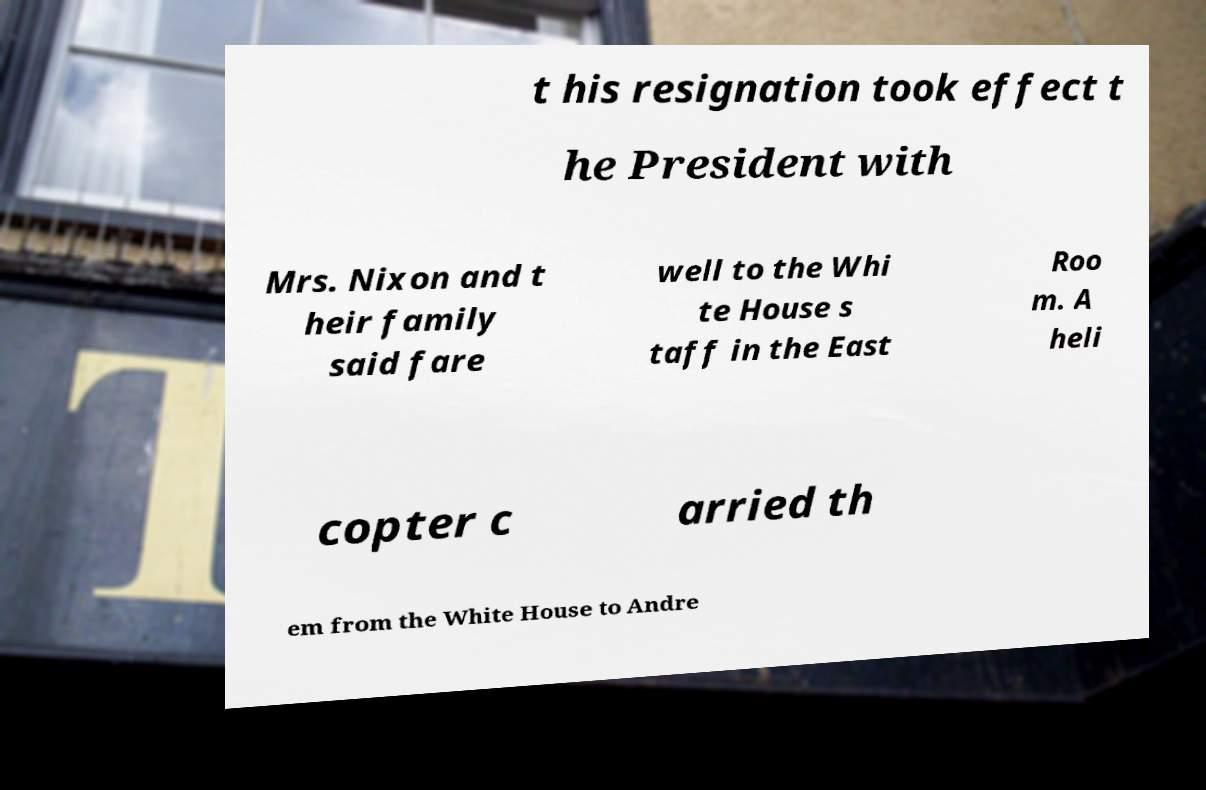Could you extract and type out the text from this image? t his resignation took effect t he President with Mrs. Nixon and t heir family said fare well to the Whi te House s taff in the East Roo m. A heli copter c arried th em from the White House to Andre 